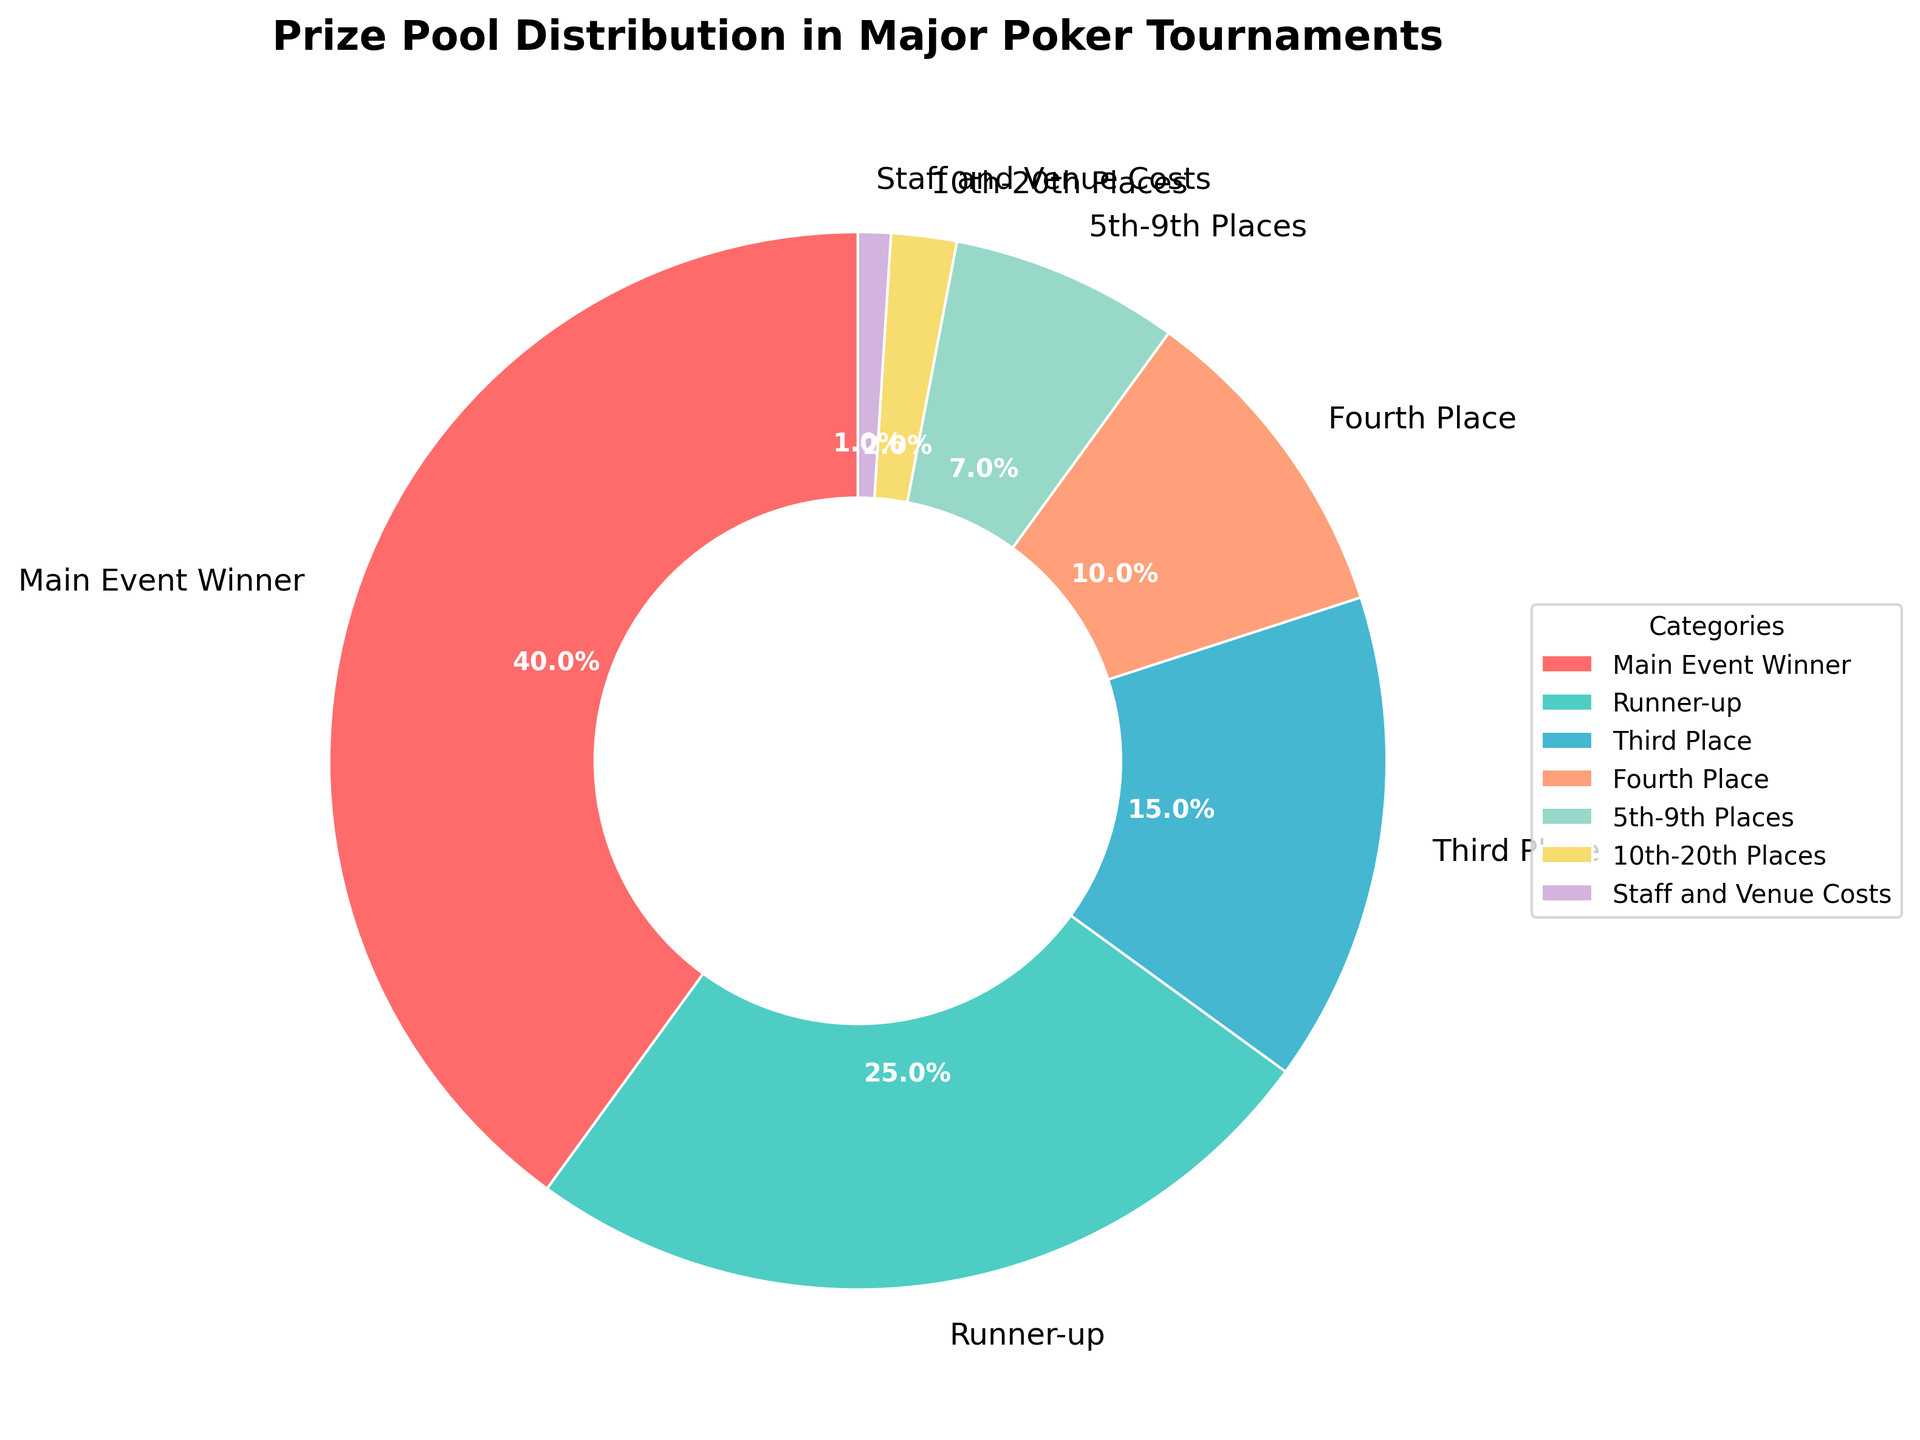What percentage of the prize pool is allocated to those who place in the top three? We need to sum the percentages for the Main Event Winner (40%), Runner-up (25%), and Third Place (15%). \( 40\% + 25\% + 15\% = 80\% \)
Answer: 80% Which category receives a higher percentage of the prize pool: Runner-up or Third Place? By comparing the percentages, Runner-up gets 25% while Third Place gets 15%. 25% is higher than 15%.
Answer: Runner-up What is the difference in prize pool percentage between the Main Event Winner and 5th-9th places? The Main Event Winner gets 40%, and 5th-9th places get 7%. The difference is \( 40\% - 7\% = 33\% \)
Answer: 33% How much more does the Runner-up receive compared to the Fourth Place? The Runner-up receives 25%, and Fourth Place receives 10%. The difference is \( 25\% - 10\% = 15\% \)
Answer: 15% What is the total percentage allocated to the top 20 participants (including the Main Event Winner, Runner-up, Third Place, Fourth Place, 5th-9th Places, 10th-20th Places)? Sum the percentages of these categories: \( 40\% + 25\% + 15\% + 10\% + 7\% + 2\% = 99\% \)
Answer: 99% Which category is represented by the largest slice in the pie chart? The Main Event Winner category at 40% is the largest slice.
Answer: Main Event Winner What is the combined percentage of the prize pool allocated to participants placing 4th to 20th? Sum the percentages for Fourth Place (10%), 5th-9th Places (7%), and 10th-20th Places (2%). \( 10\% + 7\% + 2\% = 19\% \)
Answer: 19% What percentage of the prize pool is allocated to Staff and Venue Costs? The pie chart indicates Staff and Venue Costs are allocated 1% of the prize pool.
Answer: 1% How much more percentage does the Main Event Winner get compared to the Runner-up? The Main Event Winner gets 40%, and the Runner-up gets 25%. The difference is \( 40\% - 25\% = 15\% \)
Answer: 15% 